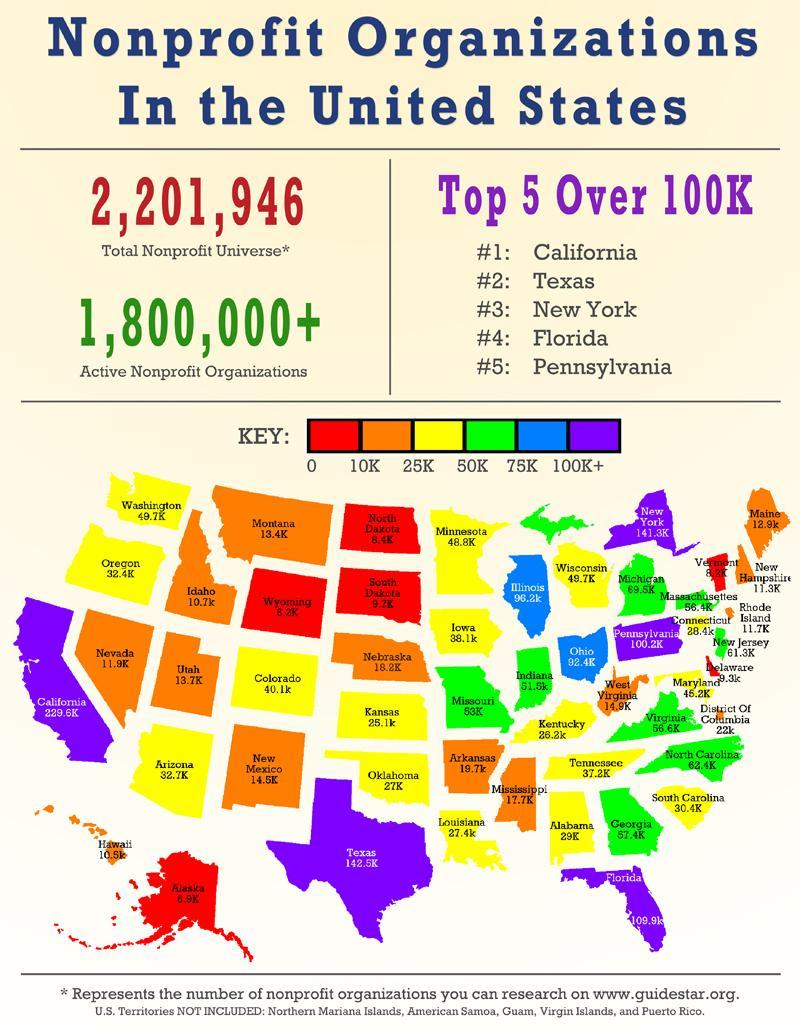What is the total no of active nonprofit organizations available in the United States?
Answer the question with a short phrase. 1,800,000+ 